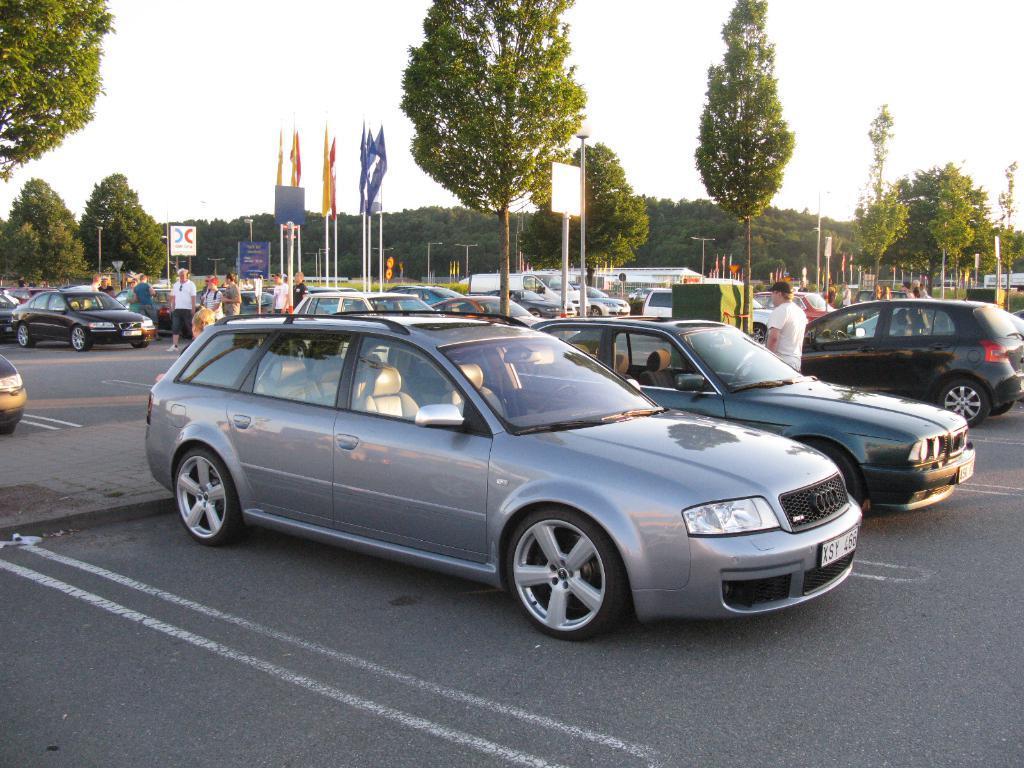Please provide a concise description of this image. In this picture we can see vehicles,persons on the ground,here we can see flags,trees and we can see sky in the background. 